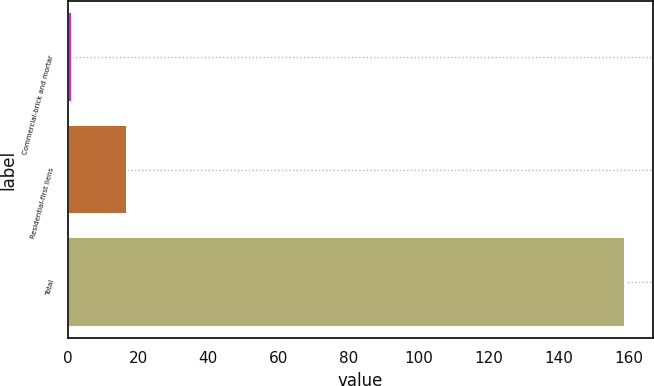<chart> <loc_0><loc_0><loc_500><loc_500><bar_chart><fcel>Commercial-brick and mortar<fcel>Residential-first liens<fcel>Total<nl><fcel>1<fcel>16.8<fcel>159<nl></chart> 